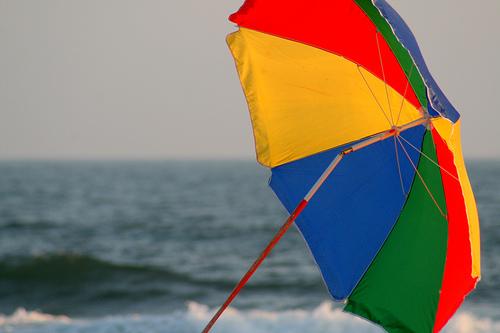Is anyone swimming?
Be succinct. No. What type of umbrella is this?
Write a very short answer. Beach. How many different colors are there?
Give a very brief answer. 4. 